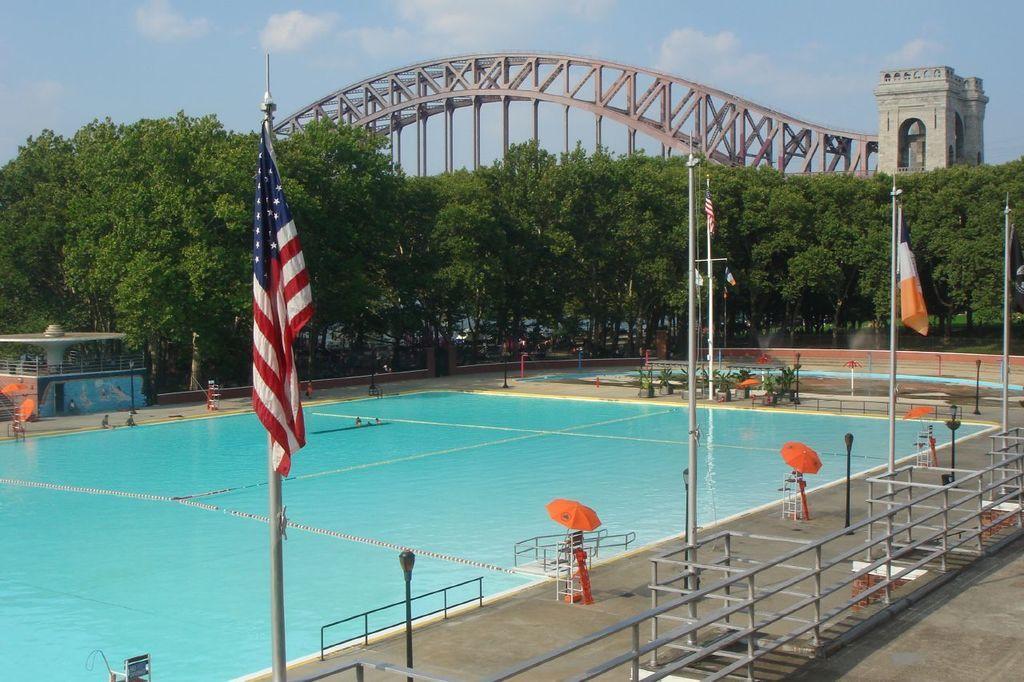Could you give a brief overview of what you see in this image? In this image we can see some flags, water, plants and other objects. In the background of the image there are trees, bridge and other objects. At the top of the image there is the sky. At the bottom of the image there is the railing, poles and other objects. 